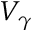<formula> <loc_0><loc_0><loc_500><loc_500>V _ { \gamma }</formula> 